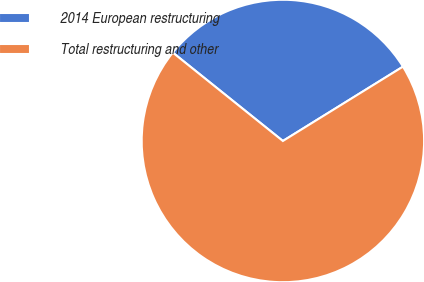Convert chart to OTSL. <chart><loc_0><loc_0><loc_500><loc_500><pie_chart><fcel>2014 European restructuring<fcel>Total restructuring and other<nl><fcel>30.41%<fcel>69.59%<nl></chart> 